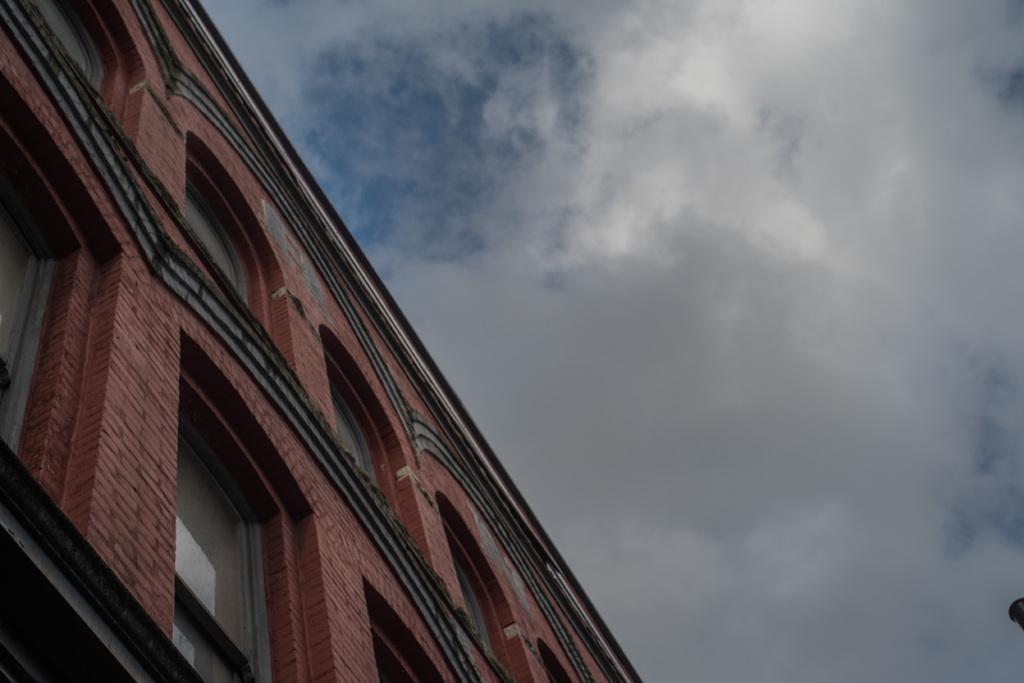Describe this image in one or two sentences. In this picture I can see a red color building and number of windows. In the background I can see the cloudy sky. 